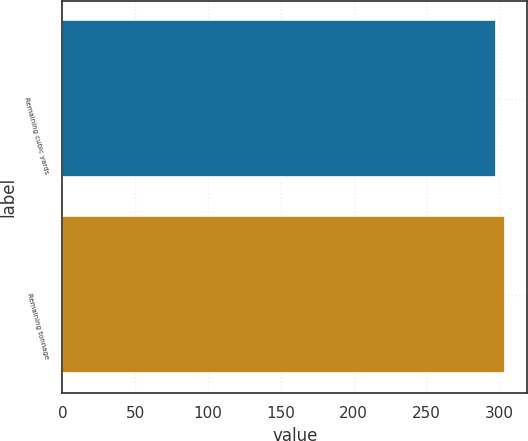Convert chart. <chart><loc_0><loc_0><loc_500><loc_500><bar_chart><fcel>Remaining cubic yards<fcel>Remaining tonnage<nl><fcel>298<fcel>304<nl></chart> 